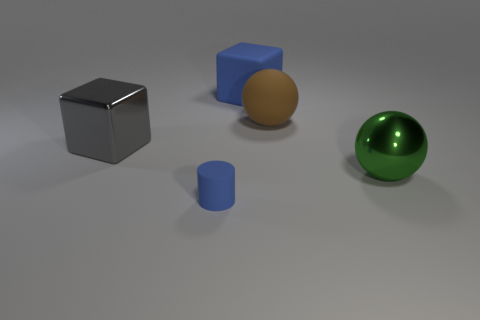How many other things are there of the same material as the brown thing?
Keep it short and to the point. 2. There is a green shiny sphere; are there any tiny cylinders behind it?
Offer a very short reply. No. There is a blue cylinder; is it the same size as the ball left of the large green ball?
Make the answer very short. No. There is a metal object that is on the right side of the large cube on the right side of the matte cylinder; what color is it?
Your answer should be compact. Green. Is the green ball the same size as the matte cylinder?
Give a very brief answer. No. There is a big object that is on the left side of the large brown sphere and on the right side of the small cylinder; what color is it?
Your answer should be very brief. Blue. How big is the matte cylinder?
Ensure brevity in your answer.  Small. Does the thing that is in front of the large green sphere have the same color as the big rubber cube?
Keep it short and to the point. Yes. Are there more spheres that are in front of the large brown thing than blocks that are in front of the gray metal thing?
Your response must be concise. Yes. Is the number of gray matte spheres greater than the number of small objects?
Your answer should be compact. No. 